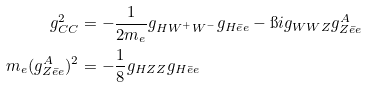<formula> <loc_0><loc_0><loc_500><loc_500>g _ { C C } ^ { 2 } & = - \frac { 1 } { 2 m _ { e } } g _ { H W ^ { + } W ^ { - } } g _ { H \bar { e } e } - \i i g _ { W W Z } g ^ { A } _ { Z \bar { e } e } \\ m _ { e } ( g ^ { A } _ { Z \bar { e } e } ) ^ { 2 } & = - \frac { 1 } { 8 } g _ { H Z Z } g _ { H \bar { e } e }</formula> 